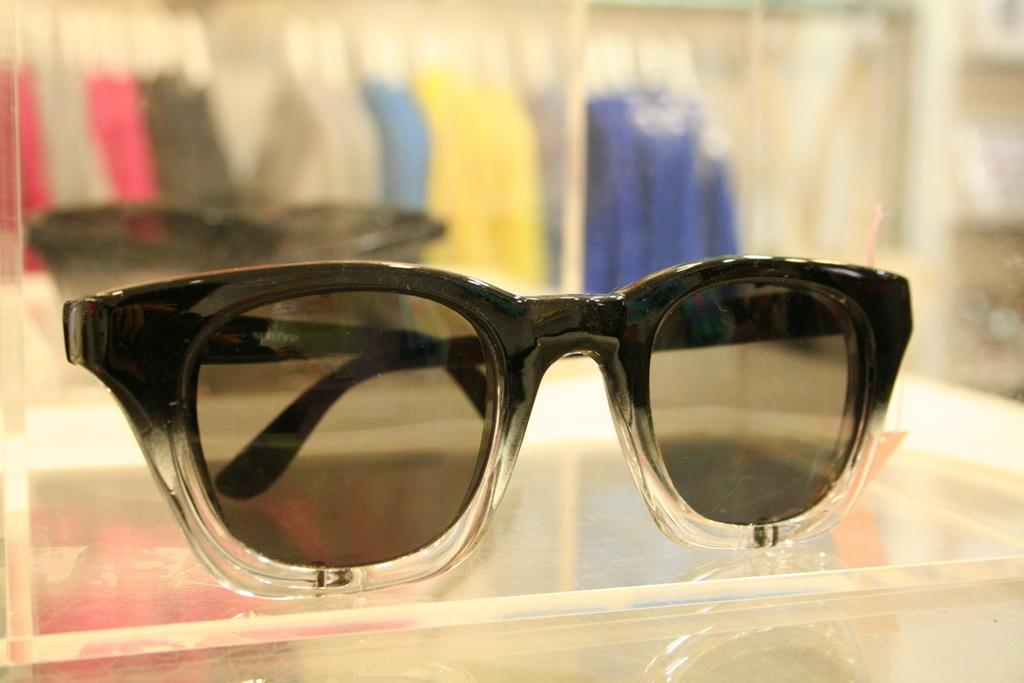What is present in the image? There are goggles in the image. Can you describe the appearance of the goggles? The background of the goggles is blurred. What type of plastic material is used to make the boats in the image? There are no boats present in the image; it only features goggles. How does the shade affect the visibility of the goggles in the image? There is no mention of shade in the image, so we cannot determine its effect on the visibility of the goggles. 